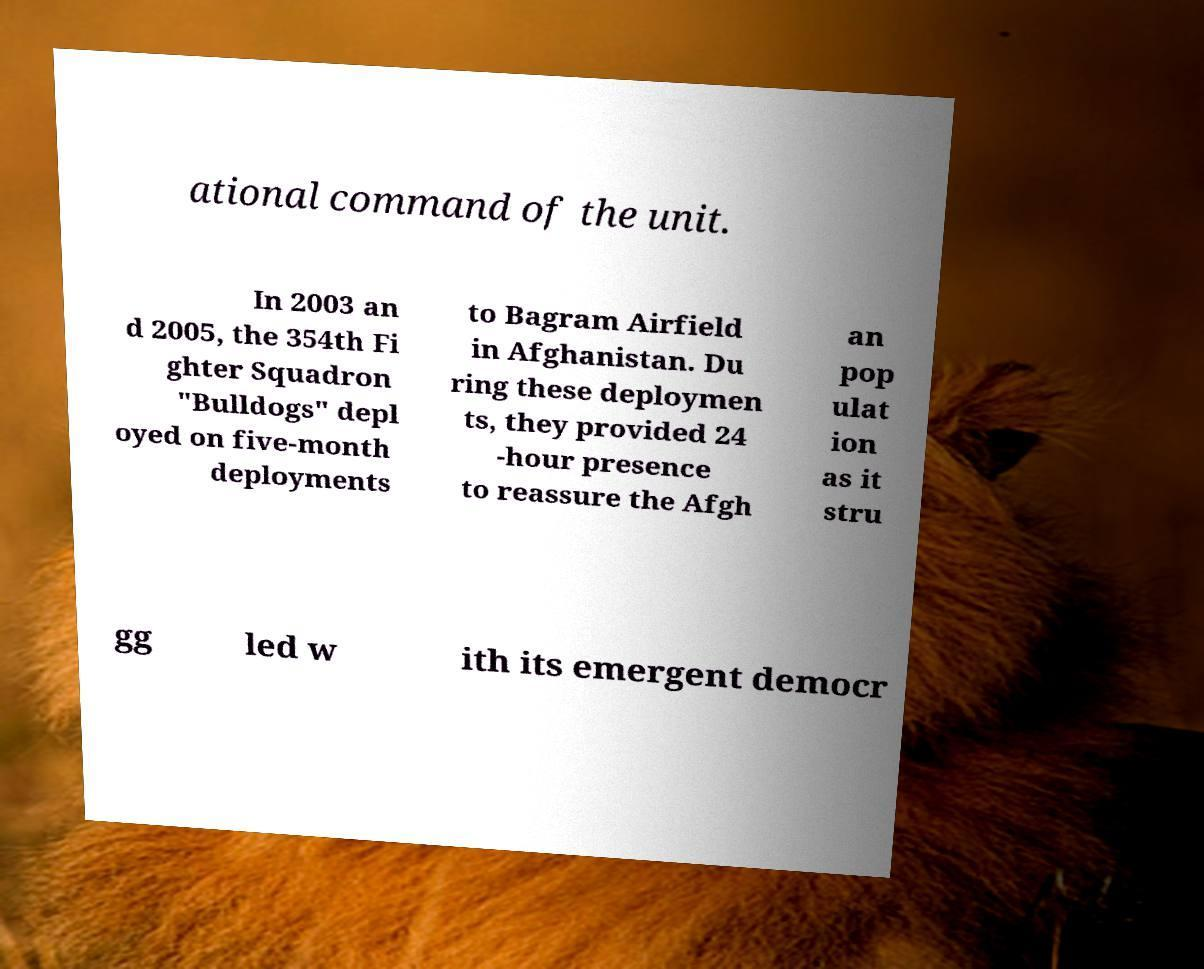What messages or text are displayed in this image? I need them in a readable, typed format. ational command of the unit. In 2003 an d 2005, the 354th Fi ghter Squadron "Bulldogs" depl oyed on five-month deployments to Bagram Airfield in Afghanistan. Du ring these deploymen ts, they provided 24 -hour presence to reassure the Afgh an pop ulat ion as it stru gg led w ith its emergent democr 